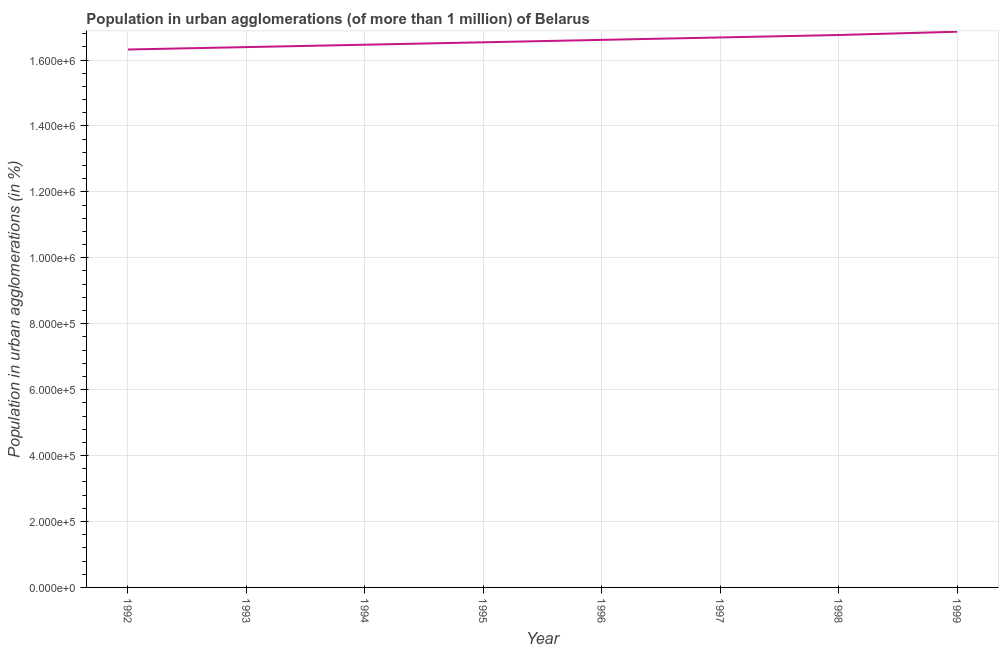What is the population in urban agglomerations in 1993?
Your answer should be very brief. 1.64e+06. Across all years, what is the maximum population in urban agglomerations?
Provide a succinct answer. 1.69e+06. Across all years, what is the minimum population in urban agglomerations?
Provide a short and direct response. 1.63e+06. What is the sum of the population in urban agglomerations?
Your response must be concise. 1.33e+07. What is the difference between the population in urban agglomerations in 1994 and 1998?
Provide a succinct answer. -2.94e+04. What is the average population in urban agglomerations per year?
Your response must be concise. 1.66e+06. What is the median population in urban agglomerations?
Your answer should be very brief. 1.66e+06. In how many years, is the population in urban agglomerations greater than 1640000 %?
Provide a succinct answer. 6. Do a majority of the years between 1998 and 1994 (inclusive) have population in urban agglomerations greater than 440000 %?
Your response must be concise. Yes. What is the ratio of the population in urban agglomerations in 1993 to that in 1995?
Your answer should be compact. 0.99. Is the population in urban agglomerations in 1992 less than that in 1999?
Offer a very short reply. Yes. What is the difference between the highest and the second highest population in urban agglomerations?
Your response must be concise. 1.00e+04. What is the difference between the highest and the lowest population in urban agglomerations?
Your answer should be very brief. 5.39e+04. How many years are there in the graph?
Keep it short and to the point. 8. Are the values on the major ticks of Y-axis written in scientific E-notation?
Make the answer very short. Yes. Does the graph contain any zero values?
Your answer should be very brief. No. Does the graph contain grids?
Your answer should be compact. Yes. What is the title of the graph?
Provide a short and direct response. Population in urban agglomerations (of more than 1 million) of Belarus. What is the label or title of the Y-axis?
Your answer should be very brief. Population in urban agglomerations (in %). What is the Population in urban agglomerations (in %) in 1992?
Give a very brief answer. 1.63e+06. What is the Population in urban agglomerations (in %) in 1993?
Your answer should be very brief. 1.64e+06. What is the Population in urban agglomerations (in %) in 1994?
Provide a succinct answer. 1.65e+06. What is the Population in urban agglomerations (in %) in 1995?
Offer a very short reply. 1.65e+06. What is the Population in urban agglomerations (in %) of 1996?
Provide a short and direct response. 1.66e+06. What is the Population in urban agglomerations (in %) in 1997?
Give a very brief answer. 1.67e+06. What is the Population in urban agglomerations (in %) of 1998?
Ensure brevity in your answer.  1.68e+06. What is the Population in urban agglomerations (in %) in 1999?
Offer a terse response. 1.69e+06. What is the difference between the Population in urban agglomerations (in %) in 1992 and 1993?
Provide a succinct answer. -7234. What is the difference between the Population in urban agglomerations (in %) in 1992 and 1994?
Keep it short and to the point. -1.45e+04. What is the difference between the Population in urban agglomerations (in %) in 1992 and 1995?
Give a very brief answer. -2.18e+04. What is the difference between the Population in urban agglomerations (in %) in 1992 and 1996?
Ensure brevity in your answer.  -2.92e+04. What is the difference between the Population in urban agglomerations (in %) in 1992 and 1997?
Offer a terse response. -3.65e+04. What is the difference between the Population in urban agglomerations (in %) in 1992 and 1998?
Your response must be concise. -4.39e+04. What is the difference between the Population in urban agglomerations (in %) in 1992 and 1999?
Keep it short and to the point. -5.39e+04. What is the difference between the Population in urban agglomerations (in %) in 1993 and 1994?
Provide a succinct answer. -7276. What is the difference between the Population in urban agglomerations (in %) in 1993 and 1995?
Give a very brief answer. -1.46e+04. What is the difference between the Population in urban agglomerations (in %) in 1993 and 1996?
Provide a short and direct response. -2.19e+04. What is the difference between the Population in urban agglomerations (in %) in 1993 and 1997?
Ensure brevity in your answer.  -2.93e+04. What is the difference between the Population in urban agglomerations (in %) in 1993 and 1998?
Your answer should be very brief. -3.67e+04. What is the difference between the Population in urban agglomerations (in %) in 1993 and 1999?
Give a very brief answer. -4.67e+04. What is the difference between the Population in urban agglomerations (in %) in 1994 and 1995?
Provide a short and direct response. -7308. What is the difference between the Population in urban agglomerations (in %) in 1994 and 1996?
Your answer should be compact. -1.47e+04. What is the difference between the Population in urban agglomerations (in %) in 1994 and 1997?
Provide a succinct answer. -2.20e+04. What is the difference between the Population in urban agglomerations (in %) in 1994 and 1998?
Keep it short and to the point. -2.94e+04. What is the difference between the Population in urban agglomerations (in %) in 1994 and 1999?
Give a very brief answer. -3.94e+04. What is the difference between the Population in urban agglomerations (in %) in 1995 and 1996?
Provide a short and direct response. -7351. What is the difference between the Population in urban agglomerations (in %) in 1995 and 1997?
Give a very brief answer. -1.47e+04. What is the difference between the Population in urban agglomerations (in %) in 1995 and 1998?
Your answer should be compact. -2.21e+04. What is the difference between the Population in urban agglomerations (in %) in 1995 and 1999?
Make the answer very short. -3.21e+04. What is the difference between the Population in urban agglomerations (in %) in 1996 and 1997?
Your response must be concise. -7363. What is the difference between the Population in urban agglomerations (in %) in 1996 and 1998?
Your answer should be compact. -1.48e+04. What is the difference between the Population in urban agglomerations (in %) in 1996 and 1999?
Give a very brief answer. -2.48e+04. What is the difference between the Population in urban agglomerations (in %) in 1997 and 1998?
Offer a terse response. -7406. What is the difference between the Population in urban agglomerations (in %) in 1997 and 1999?
Your response must be concise. -1.74e+04. What is the difference between the Population in urban agglomerations (in %) in 1998 and 1999?
Ensure brevity in your answer.  -1.00e+04. What is the ratio of the Population in urban agglomerations (in %) in 1992 to that in 1994?
Offer a terse response. 0.99. What is the ratio of the Population in urban agglomerations (in %) in 1992 to that in 1995?
Make the answer very short. 0.99. What is the ratio of the Population in urban agglomerations (in %) in 1992 to that in 1997?
Ensure brevity in your answer.  0.98. What is the ratio of the Population in urban agglomerations (in %) in 1994 to that in 1995?
Your answer should be compact. 1. What is the ratio of the Population in urban agglomerations (in %) in 1994 to that in 1996?
Make the answer very short. 0.99. What is the ratio of the Population in urban agglomerations (in %) in 1994 to that in 1997?
Make the answer very short. 0.99. What is the ratio of the Population in urban agglomerations (in %) in 1994 to that in 1998?
Offer a terse response. 0.98. What is the ratio of the Population in urban agglomerations (in %) in 1995 to that in 1996?
Give a very brief answer. 1. What is the ratio of the Population in urban agglomerations (in %) in 1995 to that in 1998?
Your response must be concise. 0.99. What is the ratio of the Population in urban agglomerations (in %) in 1995 to that in 1999?
Offer a terse response. 0.98. What is the ratio of the Population in urban agglomerations (in %) in 1996 to that in 1998?
Provide a succinct answer. 0.99. What is the ratio of the Population in urban agglomerations (in %) in 1996 to that in 1999?
Your answer should be very brief. 0.98. 